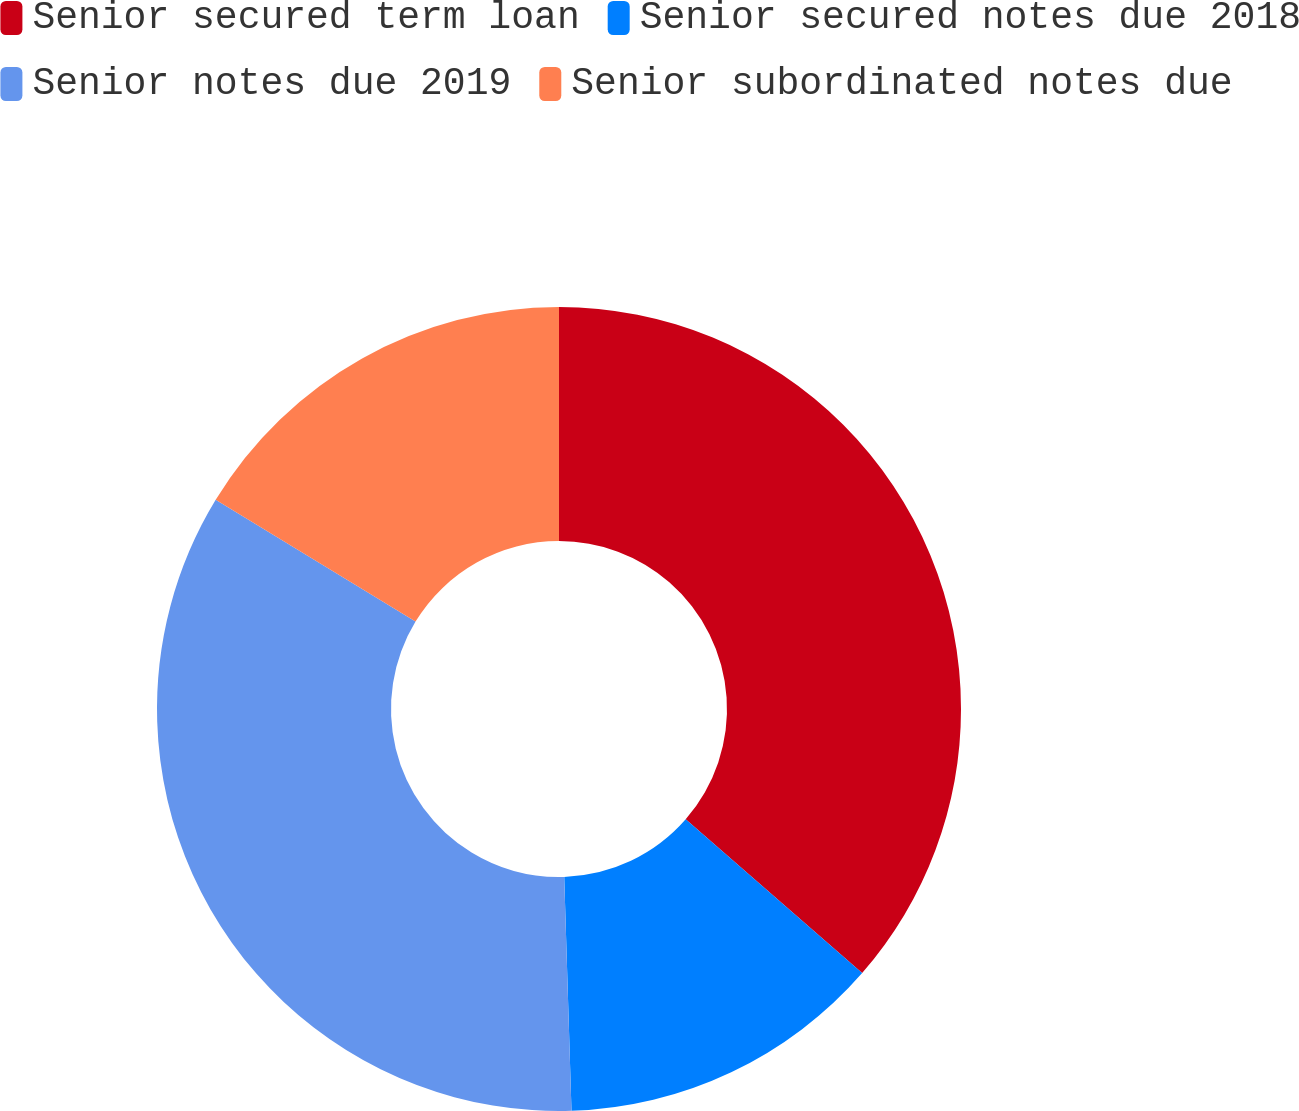Convert chart to OTSL. <chart><loc_0><loc_0><loc_500><loc_500><pie_chart><fcel>Senior secured term loan<fcel>Senior secured notes due 2018<fcel>Senior notes due 2019<fcel>Senior subordinated notes due<nl><fcel>36.4%<fcel>13.1%<fcel>34.2%<fcel>16.29%<nl></chart> 